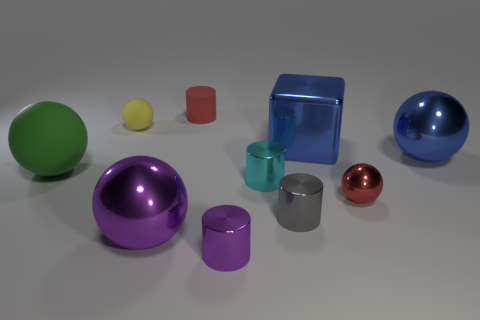Subtract all blue balls. How many balls are left? 4 Subtract 1 balls. How many balls are left? 4 Subtract all small yellow balls. How many balls are left? 4 Subtract all brown spheres. Subtract all yellow cylinders. How many spheres are left? 5 Add 9 big blue shiny blocks. How many big blue shiny blocks exist? 10 Subtract 1 red balls. How many objects are left? 9 Subtract all cubes. How many objects are left? 9 Subtract all blue metal cylinders. Subtract all green matte spheres. How many objects are left? 9 Add 2 blue metal spheres. How many blue metal spheres are left? 3 